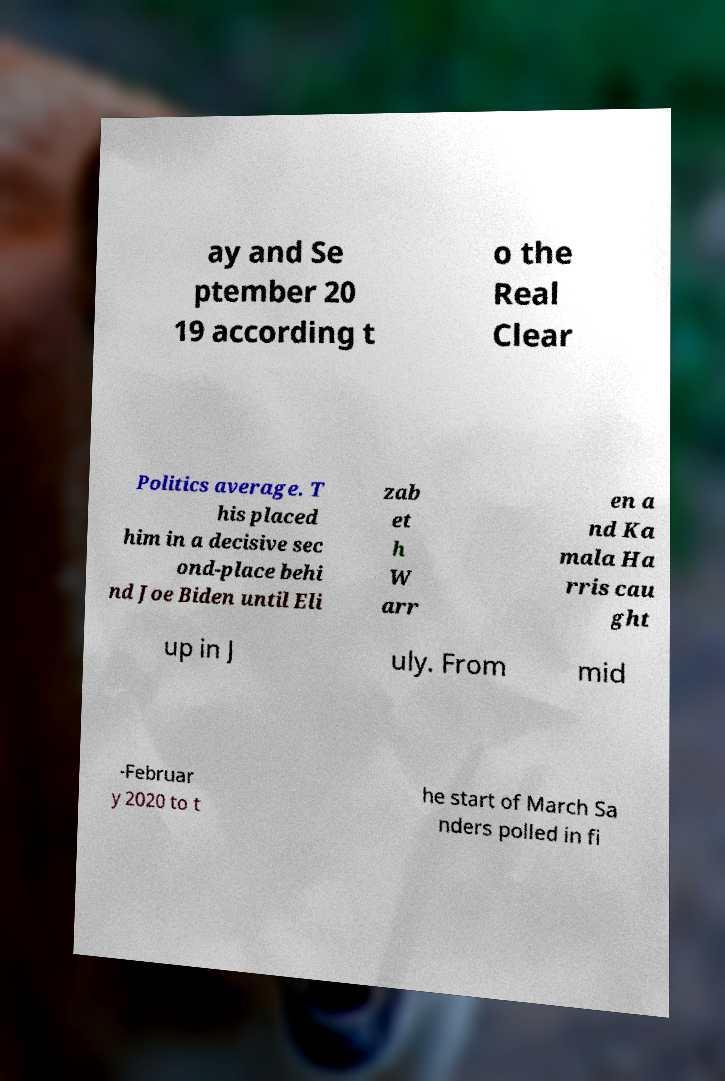Please read and relay the text visible in this image. What does it say? ay and Se ptember 20 19 according t o the Real Clear Politics average. T his placed him in a decisive sec ond-place behi nd Joe Biden until Eli zab et h W arr en a nd Ka mala Ha rris cau ght up in J uly. From mid -Februar y 2020 to t he start of March Sa nders polled in fi 